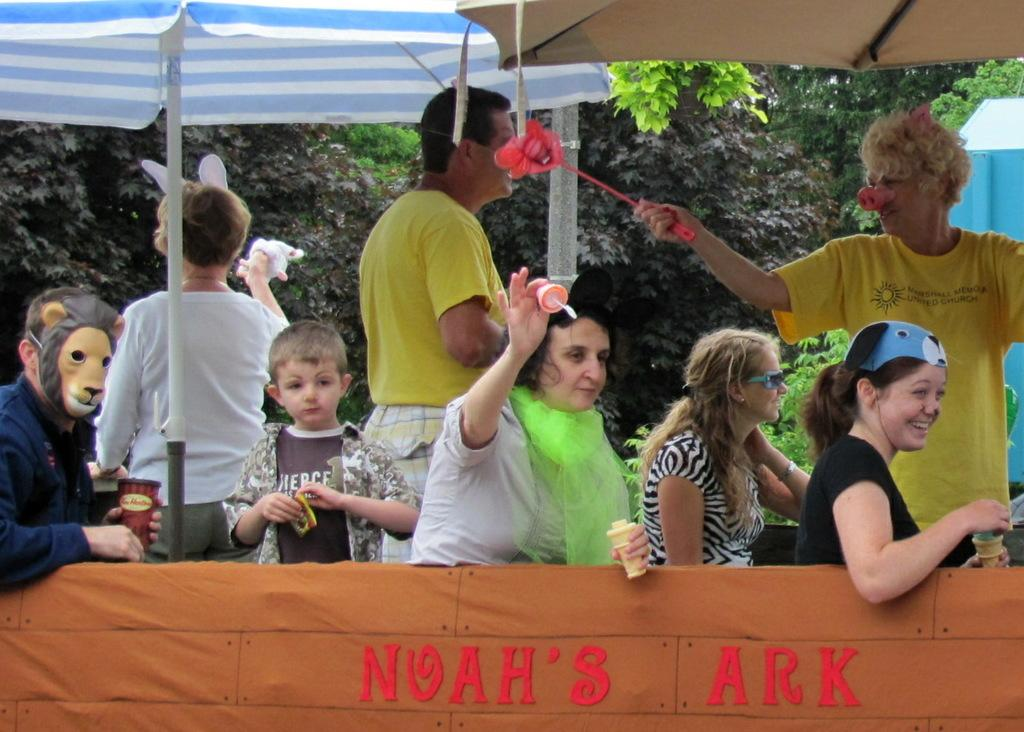Who or what is present in the image? There are people in the image. What are the people holding in their hands? The people are holding something, but the facts do not specify what it is. What are the people wearing on their faces? The people are wearing masks. What can be seen in the image to provide shade or protection from the rain? There are umbrellas visible in the image. What can be seen in the distance in the image? There are trees in the background of the image. What sense can be experienced by the people in the image? The facts provided do not mention any specific sense being experienced by the people in the image. 